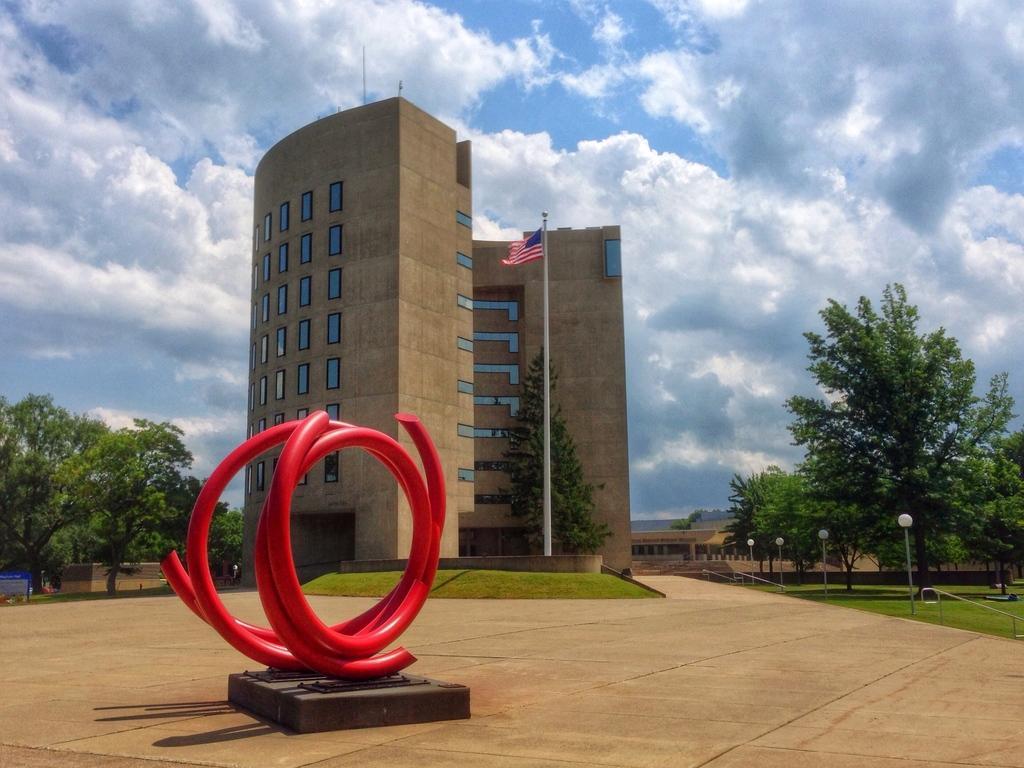In one or two sentences, can you explain what this image depicts? In the center of the image we can see building, flag, pole and tree. On the right side of the image there is a tree, poles and grass. On the left side of the image there are trees. In the background we can see sky and clouds. 